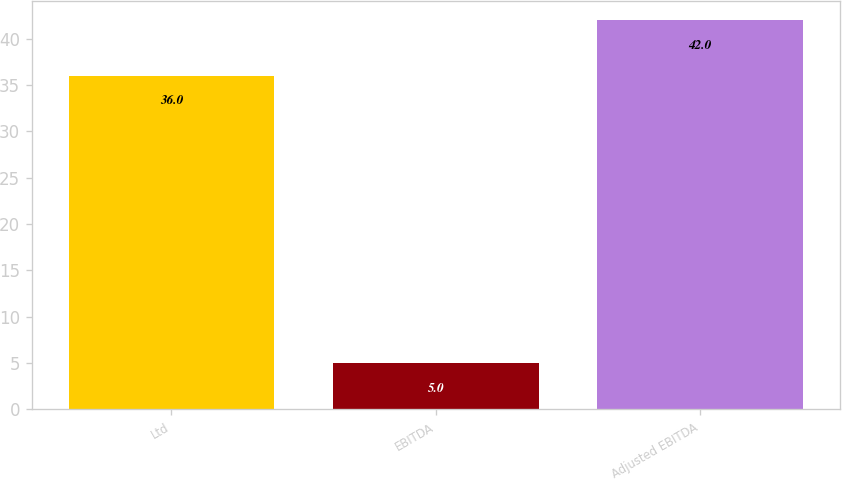Convert chart. <chart><loc_0><loc_0><loc_500><loc_500><bar_chart><fcel>Ltd<fcel>EBITDA<fcel>Adjusted EBITDA<nl><fcel>36<fcel>5<fcel>42<nl></chart> 